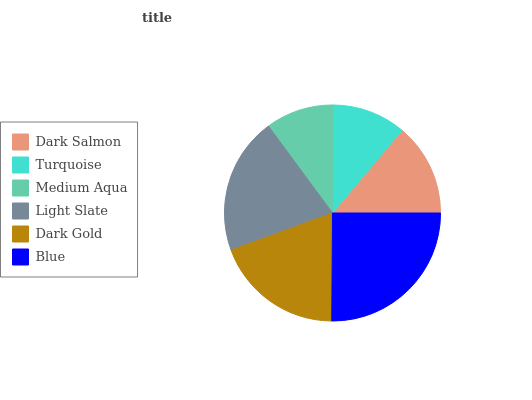Is Medium Aqua the minimum?
Answer yes or no. Yes. Is Blue the maximum?
Answer yes or no. Yes. Is Turquoise the minimum?
Answer yes or no. No. Is Turquoise the maximum?
Answer yes or no. No. Is Dark Salmon greater than Turquoise?
Answer yes or no. Yes. Is Turquoise less than Dark Salmon?
Answer yes or no. Yes. Is Turquoise greater than Dark Salmon?
Answer yes or no. No. Is Dark Salmon less than Turquoise?
Answer yes or no. No. Is Dark Gold the high median?
Answer yes or no. Yes. Is Dark Salmon the low median?
Answer yes or no. Yes. Is Dark Salmon the high median?
Answer yes or no. No. Is Turquoise the low median?
Answer yes or no. No. 